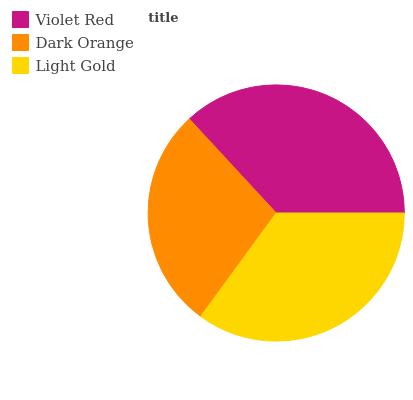Is Dark Orange the minimum?
Answer yes or no. Yes. Is Violet Red the maximum?
Answer yes or no. Yes. Is Light Gold the minimum?
Answer yes or no. No. Is Light Gold the maximum?
Answer yes or no. No. Is Light Gold greater than Dark Orange?
Answer yes or no. Yes. Is Dark Orange less than Light Gold?
Answer yes or no. Yes. Is Dark Orange greater than Light Gold?
Answer yes or no. No. Is Light Gold less than Dark Orange?
Answer yes or no. No. Is Light Gold the high median?
Answer yes or no. Yes. Is Light Gold the low median?
Answer yes or no. Yes. Is Violet Red the high median?
Answer yes or no. No. Is Dark Orange the low median?
Answer yes or no. No. 